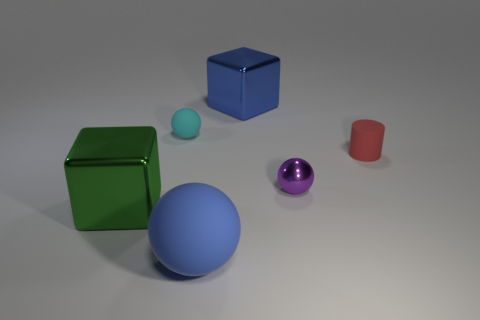What number of tiny yellow things are there?
Offer a very short reply. 0. What is the material of the big cube that is behind the big object left of the cyan object?
Offer a terse response. Metal. There is a object on the left side of the tiny thing that is left of the metallic block behind the rubber cylinder; what color is it?
Offer a very short reply. Green. Does the shiny sphere have the same color as the big rubber sphere?
Your answer should be compact. No. What number of gray spheres are the same size as the blue cube?
Offer a very short reply. 0. Are there more large blue matte spheres behind the small purple thing than cyan spheres that are on the left side of the cyan sphere?
Keep it short and to the point. No. There is a metal cube that is behind the tiny matte object that is to the right of the tiny purple shiny object; what is its color?
Make the answer very short. Blue. Do the tiny red object and the tiny purple sphere have the same material?
Your answer should be compact. No. Is there a tiny yellow matte object that has the same shape as the green metal thing?
Give a very brief answer. No. Is the color of the cube that is in front of the big blue shiny cube the same as the tiny rubber cylinder?
Your answer should be very brief. No. 